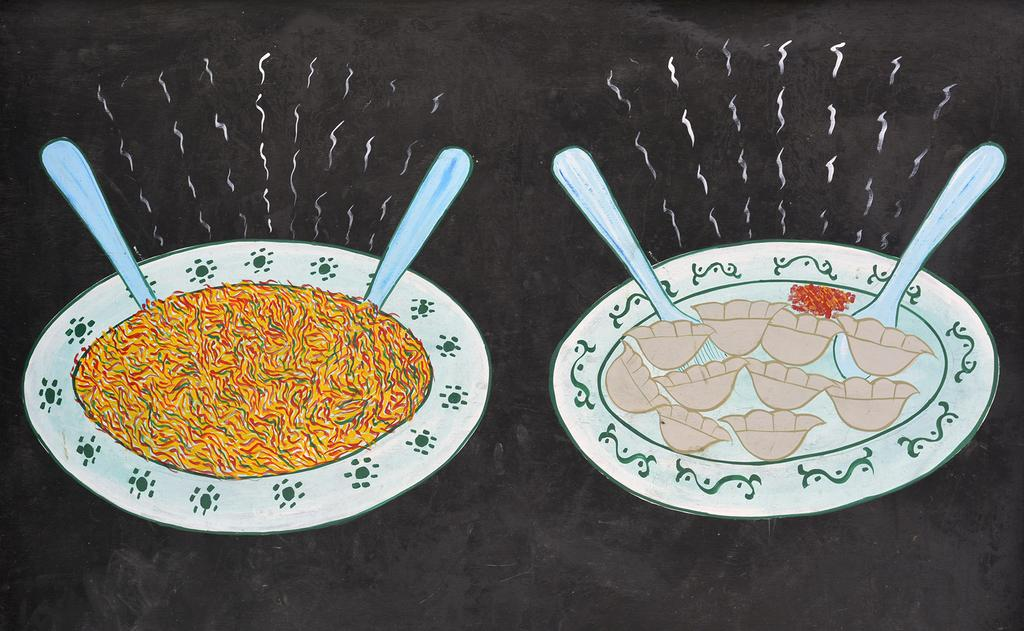What is the main subject of the image? There is a drawing in the image. What objects are depicted in the drawing? The drawing contains 2 white plates with food items on them, and there are 2 spoons in the drawing. What is the color of the plates in the drawing? The plates in the drawing are white. What is the background color of the drawing? The background of the drawing is black. What type of behavior does the grandmother exhibit in the image? There is no grandmother present in the image, so it is not possible to describe her behavior. What type of soda is being served on the plates in the image? There is no soda present in the image; the plates contain food items. 